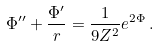Convert formula to latex. <formula><loc_0><loc_0><loc_500><loc_500>\Phi ^ { \prime \prime } + \frac { \Phi ^ { \prime } } { r } = \frac { 1 } { 9 Z ^ { 2 } } e ^ { 2 \Phi } \, .</formula> 